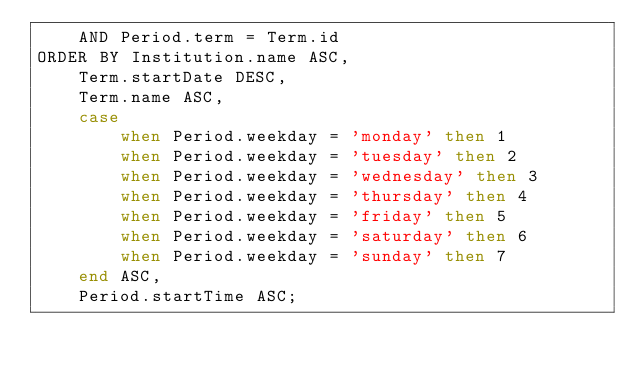<code> <loc_0><loc_0><loc_500><loc_500><_SQL_>    AND Period.term = Term.id
ORDER BY Institution.name ASC,
    Term.startDate DESC,
    Term.name ASC,
    case
        when Period.weekday = 'monday' then 1
        when Period.weekday = 'tuesday' then 2
        when Period.weekday = 'wednesday' then 3
        when Period.weekday = 'thursday' then 4
        when Period.weekday = 'friday' then 5
        when Period.weekday = 'saturday' then 6
        when Period.weekday = 'sunday' then 7
    end ASC,
    Period.startTime ASC;</code> 